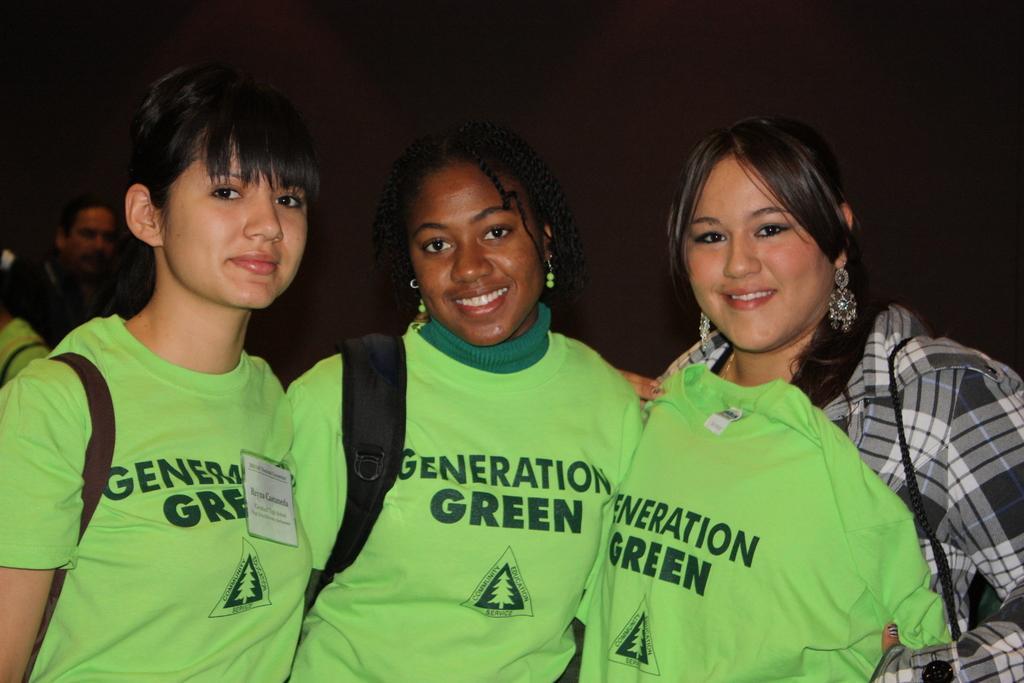Describe this image in one or two sentences. Here in this picture we can see three women standing over a place and we can see all of them are smiling and carrying bags with them and the two women on the left side are wearing green colored t shits on them and the woman on the right side is holding a t shirt with her and behind her also we can see other people present over there. 